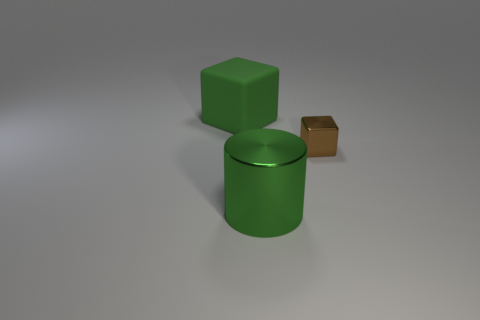Are there more big red matte blocks than small shiny objects?
Ensure brevity in your answer.  No. What number of objects are big green objects that are on the left side of the green metallic cylinder or shiny blocks?
Make the answer very short. 2. Are there any matte objects that have the same size as the green metal object?
Make the answer very short. Yes. Is the number of large matte objects less than the number of red metal things?
Offer a terse response. No. How many cylinders are either big green shiny objects or brown objects?
Ensure brevity in your answer.  1. What number of big rubber objects are the same color as the big cube?
Make the answer very short. 0. There is a object that is both left of the brown cube and behind the cylinder; what is its size?
Provide a succinct answer. Large. Is the number of green cylinders in front of the large shiny cylinder less than the number of green cylinders?
Offer a very short reply. Yes. Is the material of the brown block the same as the cylinder?
Offer a very short reply. Yes. How many objects are either shiny objects or tiny green metallic spheres?
Make the answer very short. 2. 